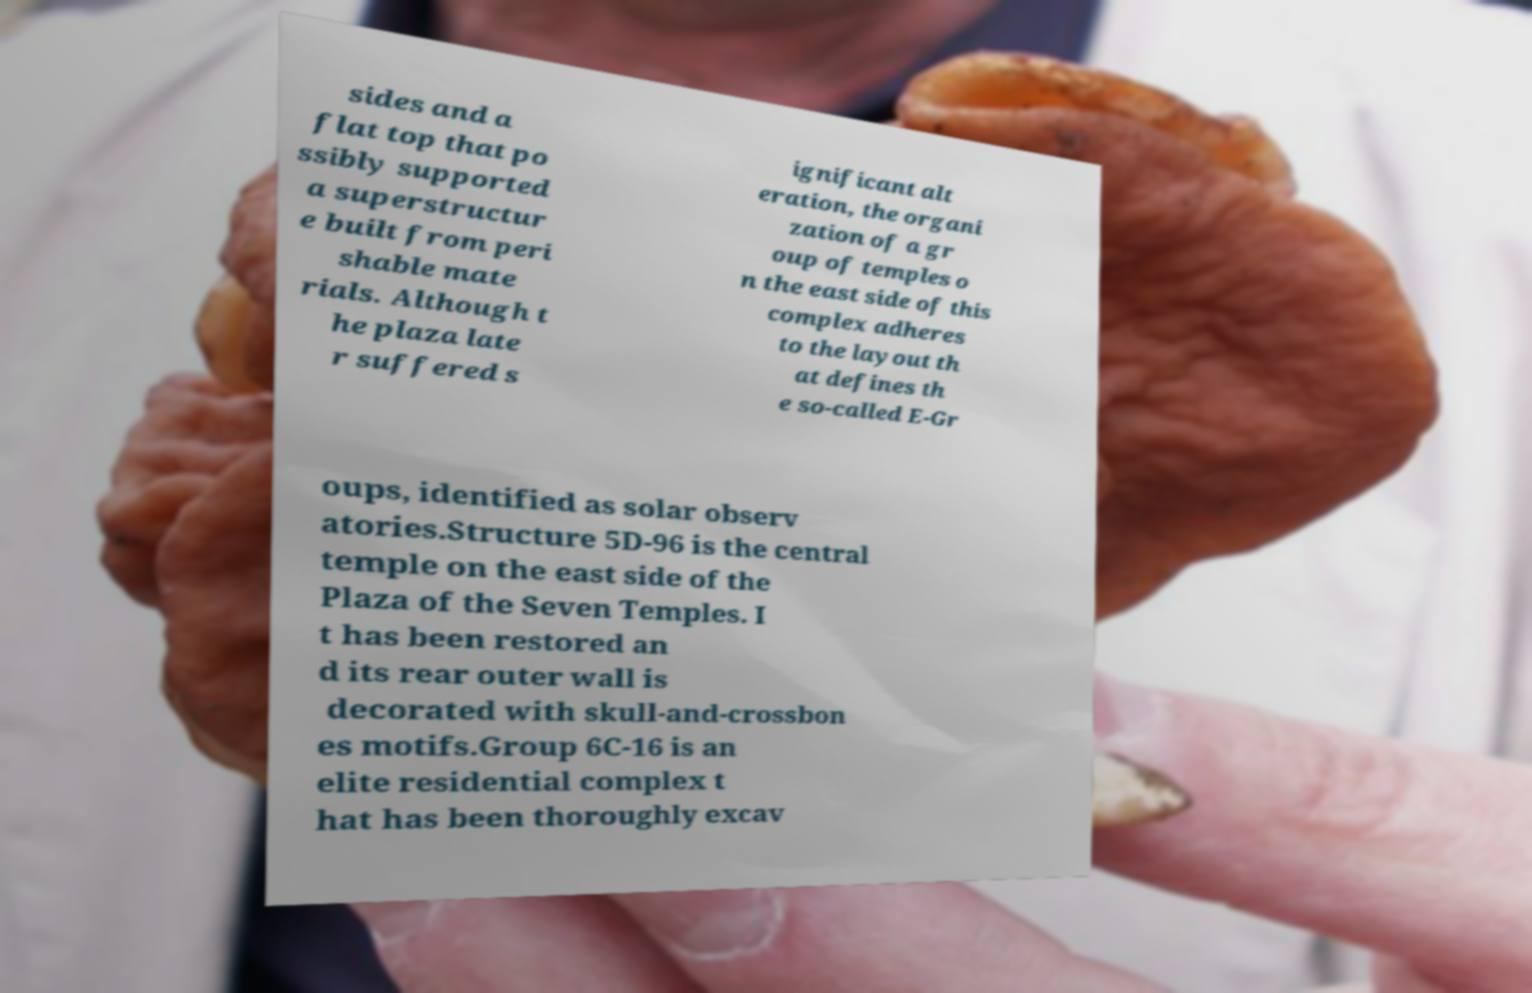Please identify and transcribe the text found in this image. sides and a flat top that po ssibly supported a superstructur e built from peri shable mate rials. Although t he plaza late r suffered s ignificant alt eration, the organi zation of a gr oup of temples o n the east side of this complex adheres to the layout th at defines th e so-called E-Gr oups, identified as solar observ atories.Structure 5D-96 is the central temple on the east side of the Plaza of the Seven Temples. I t has been restored an d its rear outer wall is decorated with skull-and-crossbon es motifs.Group 6C-16 is an elite residential complex t hat has been thoroughly excav 